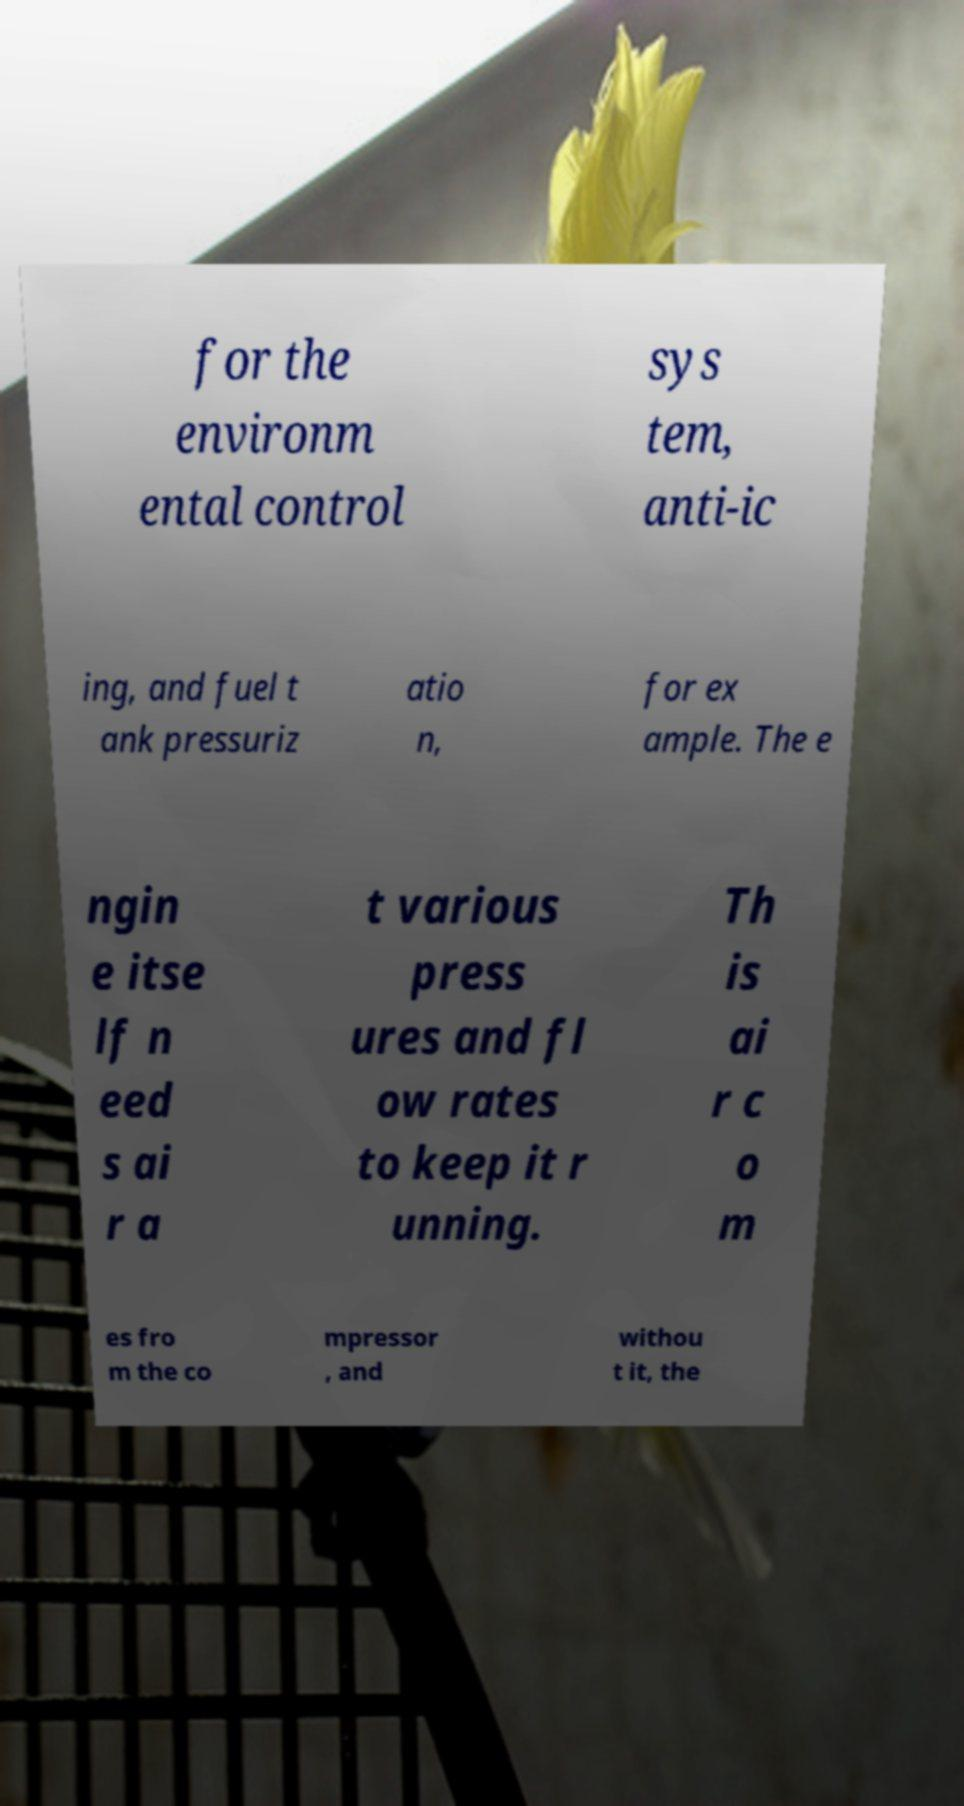Could you extract and type out the text from this image? for the environm ental control sys tem, anti-ic ing, and fuel t ank pressuriz atio n, for ex ample. The e ngin e itse lf n eed s ai r a t various press ures and fl ow rates to keep it r unning. Th is ai r c o m es fro m the co mpressor , and withou t it, the 